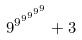Convert formula to latex. <formula><loc_0><loc_0><loc_500><loc_500>9 ^ { 9 ^ { 9 ^ { 9 ^ { 9 ^ { 9 } } } } } + 3</formula> 